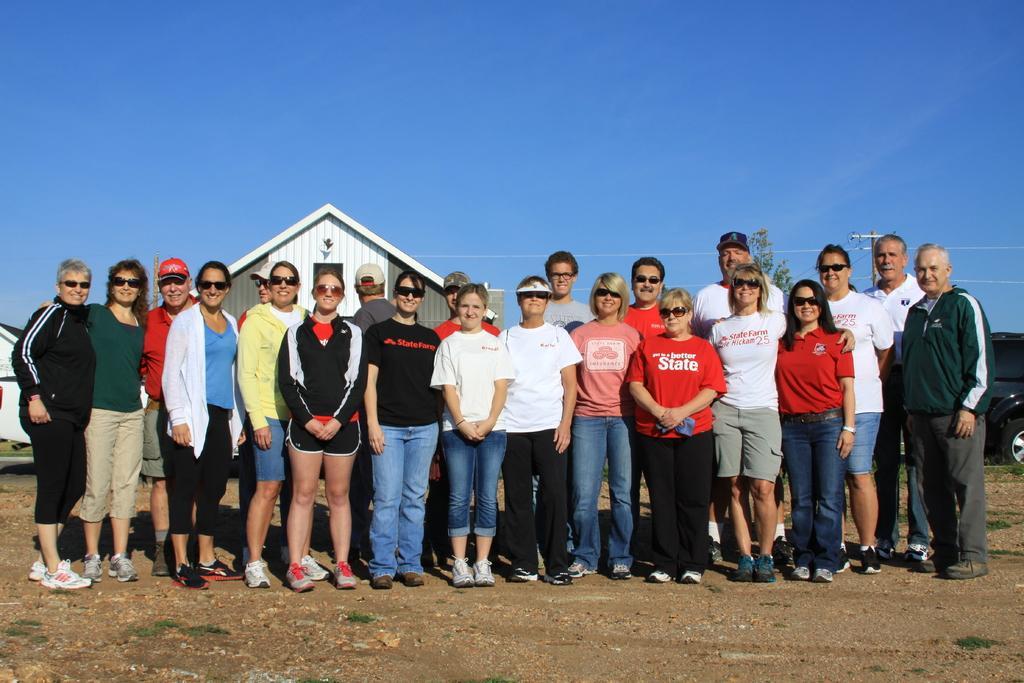How would you summarize this image in a sentence or two? This picture is clicked outside. In the center we can see the group of people standing on the ground and in the background, we can see the sky, a vehicle and the houses and some other items. 